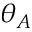<formula> <loc_0><loc_0><loc_500><loc_500>\theta _ { A }</formula> 